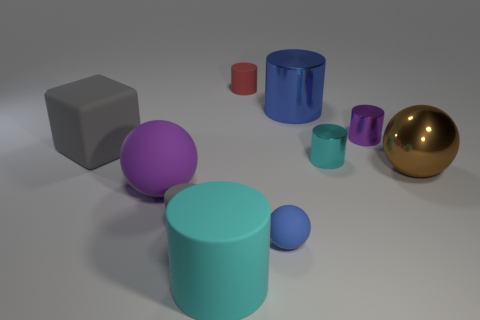Subtract all matte balls. How many balls are left? 1 Subtract 1 spheres. How many spheres are left? 2 Subtract all gray cylinders. How many cylinders are left? 5 Add 7 purple objects. How many purple objects are left? 9 Add 9 purple rubber objects. How many purple rubber objects exist? 10 Subtract 0 brown cubes. How many objects are left? 10 Subtract all blocks. How many objects are left? 9 Subtract all blue cylinders. Subtract all gray balls. How many cylinders are left? 5 Subtract all cyan balls. How many cyan cylinders are left? 2 Subtract all large brown metal things. Subtract all big cylinders. How many objects are left? 7 